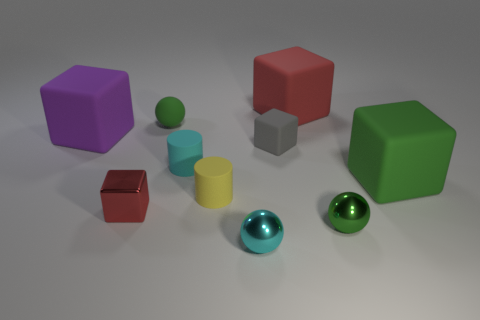Subtract all green cubes. How many cubes are left? 4 Subtract all big red matte blocks. How many blocks are left? 4 Subtract all blue blocks. Subtract all yellow balls. How many blocks are left? 5 Subtract all cylinders. How many objects are left? 8 Subtract all yellow things. Subtract all small red cubes. How many objects are left? 8 Add 2 small metal objects. How many small metal objects are left? 5 Add 3 big cyan matte cylinders. How many big cyan matte cylinders exist? 3 Subtract 0 red balls. How many objects are left? 10 